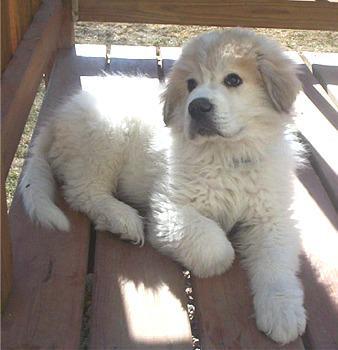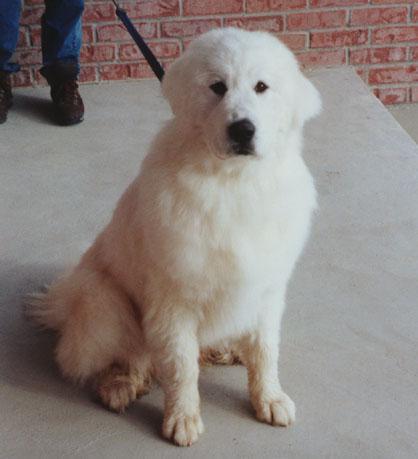The first image is the image on the left, the second image is the image on the right. Considering the images on both sides, is "A man is standing while holding a big white dog." valid? Answer yes or no. No. The first image is the image on the left, the second image is the image on the right. Evaluate the accuracy of this statement regarding the images: "There is a human holding a dog in the image on the right.". Is it true? Answer yes or no. No. 